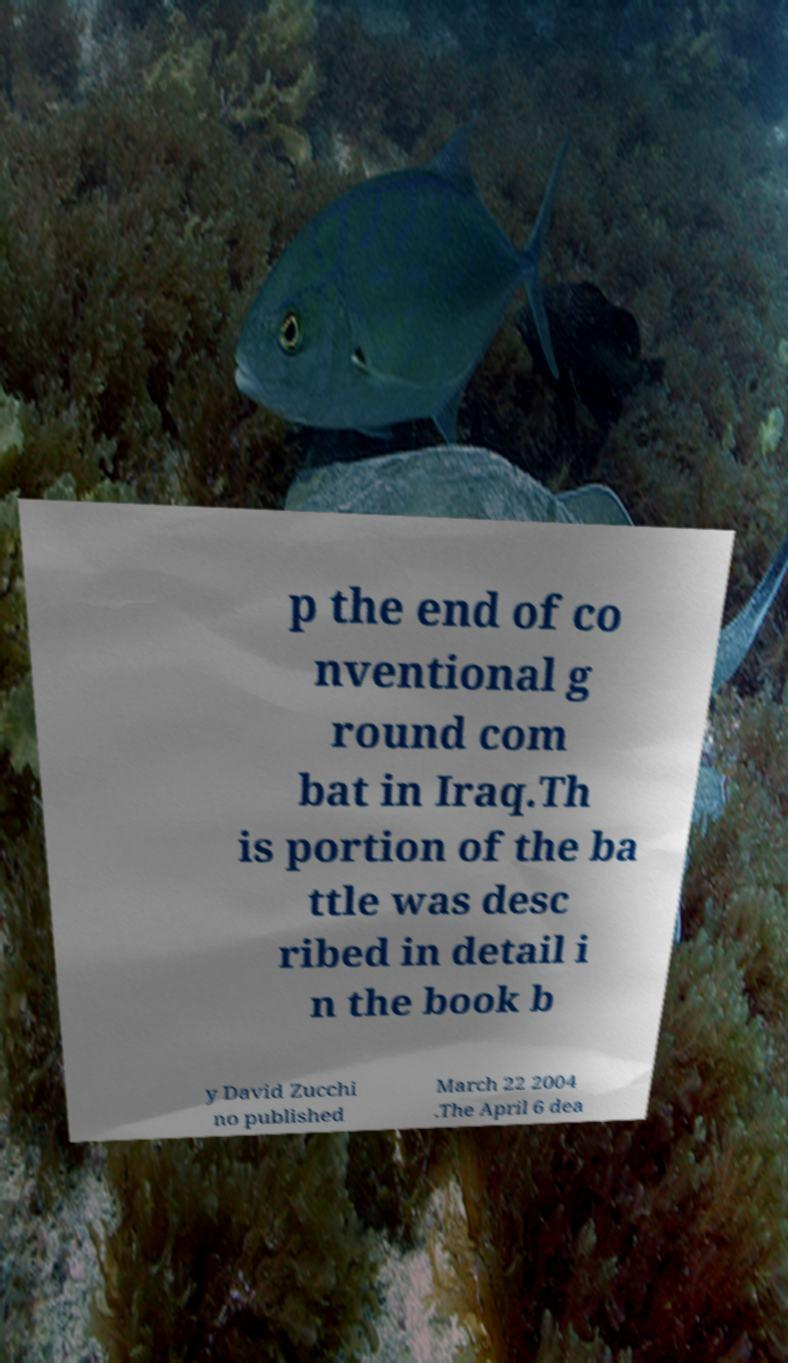Could you assist in decoding the text presented in this image and type it out clearly? p the end of co nventional g round com bat in Iraq.Th is portion of the ba ttle was desc ribed in detail i n the book b y David Zucchi no published March 22 2004 .The April 6 dea 